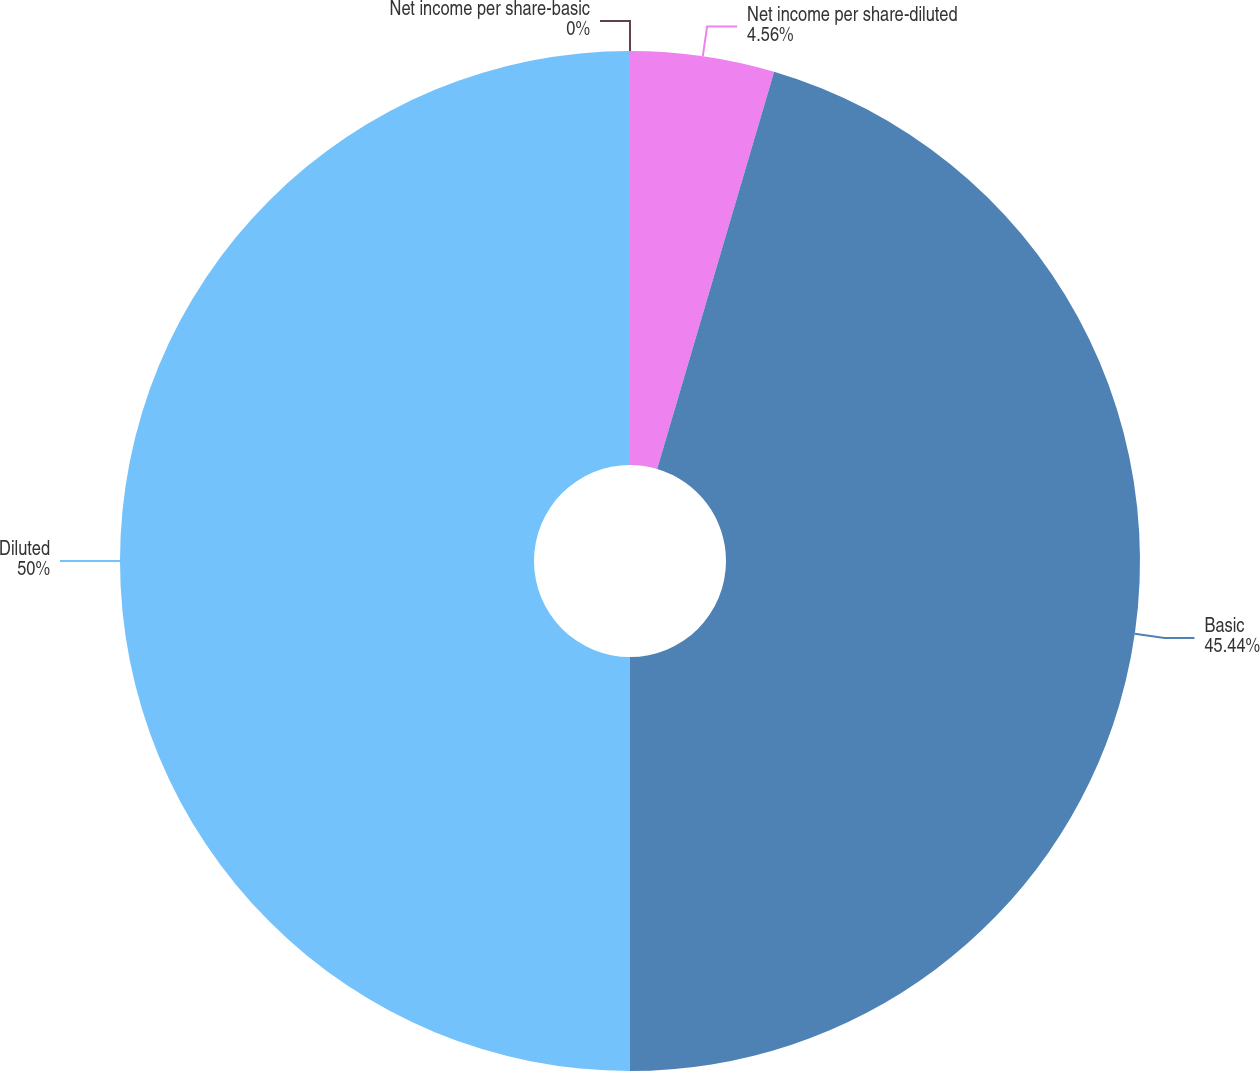Convert chart. <chart><loc_0><loc_0><loc_500><loc_500><pie_chart><fcel>Net income per share-basic<fcel>Net income per share-diluted<fcel>Basic<fcel>Diluted<nl><fcel>0.0%<fcel>4.56%<fcel>45.44%<fcel>50.0%<nl></chart> 